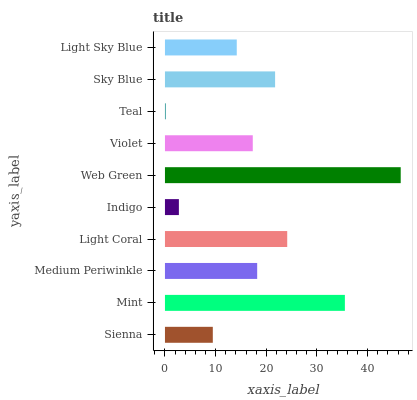Is Teal the minimum?
Answer yes or no. Yes. Is Web Green the maximum?
Answer yes or no. Yes. Is Mint the minimum?
Answer yes or no. No. Is Mint the maximum?
Answer yes or no. No. Is Mint greater than Sienna?
Answer yes or no. Yes. Is Sienna less than Mint?
Answer yes or no. Yes. Is Sienna greater than Mint?
Answer yes or no. No. Is Mint less than Sienna?
Answer yes or no. No. Is Medium Periwinkle the high median?
Answer yes or no. Yes. Is Violet the low median?
Answer yes or no. Yes. Is Violet the high median?
Answer yes or no. No. Is Teal the low median?
Answer yes or no. No. 